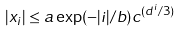Convert formula to latex. <formula><loc_0><loc_0><loc_500><loc_500>| x _ { i } | \leq a \exp ( - | i | / b ) c ^ { ( d ^ { i } / 3 ) }</formula> 